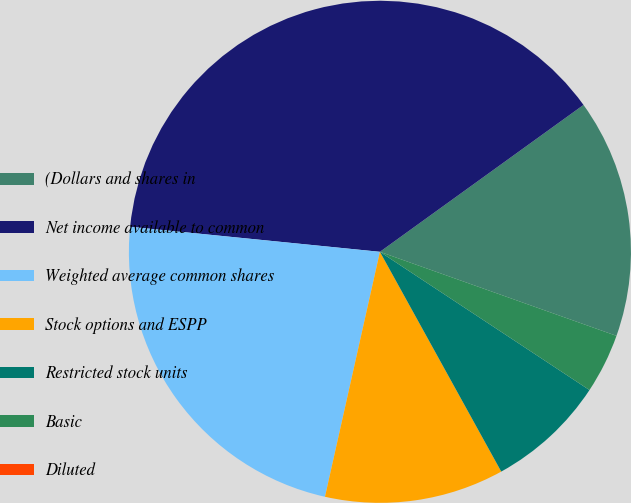Convert chart to OTSL. <chart><loc_0><loc_0><loc_500><loc_500><pie_chart><fcel>(Dollars and shares in<fcel>Net income available to common<fcel>Weighted average common shares<fcel>Stock options and ESPP<fcel>Restricted stock units<fcel>Basic<fcel>Diluted<nl><fcel>15.38%<fcel>38.46%<fcel>23.08%<fcel>11.54%<fcel>7.69%<fcel>3.85%<fcel>0.0%<nl></chart> 